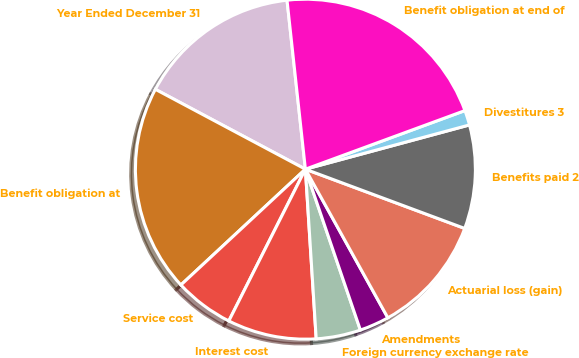Convert chart. <chart><loc_0><loc_0><loc_500><loc_500><pie_chart><fcel>Year Ended December 31<fcel>Benefit obligation at<fcel>Service cost<fcel>Interest cost<fcel>Foreign currency exchange rate<fcel>Amendments<fcel>Actuarial loss (gain)<fcel>Benefits paid 2<fcel>Divestitures 3<fcel>Benefit obligation at end of<nl><fcel>15.49%<fcel>19.71%<fcel>5.64%<fcel>8.45%<fcel>4.23%<fcel>2.82%<fcel>11.27%<fcel>9.86%<fcel>1.41%<fcel>21.12%<nl></chart> 